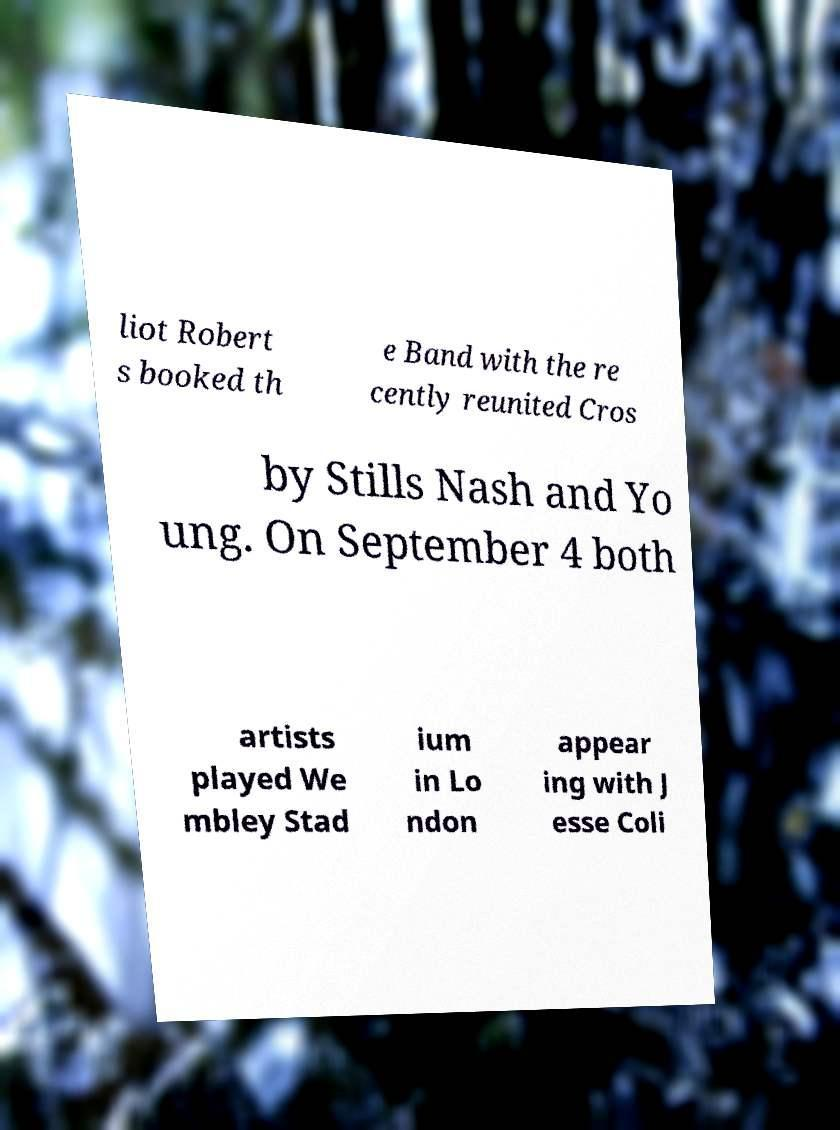For documentation purposes, I need the text within this image transcribed. Could you provide that? liot Robert s booked th e Band with the re cently reunited Cros by Stills Nash and Yo ung. On September 4 both artists played We mbley Stad ium in Lo ndon appear ing with J esse Coli 